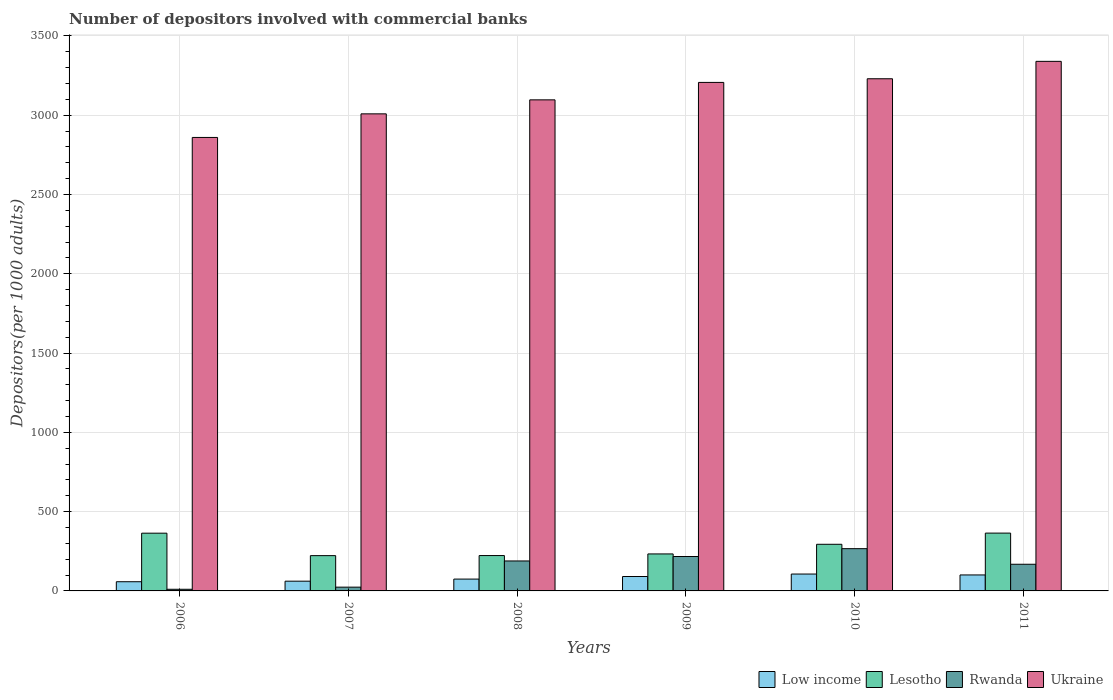How many groups of bars are there?
Offer a very short reply. 6. Are the number of bars per tick equal to the number of legend labels?
Keep it short and to the point. Yes. How many bars are there on the 3rd tick from the left?
Make the answer very short. 4. In how many cases, is the number of bars for a given year not equal to the number of legend labels?
Make the answer very short. 0. What is the number of depositors involved with commercial banks in Low income in 2008?
Provide a succinct answer. 74.6. Across all years, what is the maximum number of depositors involved with commercial banks in Lesotho?
Your response must be concise. 364.57. Across all years, what is the minimum number of depositors involved with commercial banks in Ukraine?
Provide a succinct answer. 2859.61. What is the total number of depositors involved with commercial banks in Ukraine in the graph?
Provide a succinct answer. 1.87e+04. What is the difference between the number of depositors involved with commercial banks in Ukraine in 2008 and that in 2010?
Your answer should be compact. -133.02. What is the difference between the number of depositors involved with commercial banks in Ukraine in 2007 and the number of depositors involved with commercial banks in Low income in 2006?
Offer a terse response. 2950.4. What is the average number of depositors involved with commercial banks in Rwanda per year?
Make the answer very short. 145.79. In the year 2010, what is the difference between the number of depositors involved with commercial banks in Rwanda and number of depositors involved with commercial banks in Low income?
Offer a terse response. 159.97. In how many years, is the number of depositors involved with commercial banks in Lesotho greater than 1200?
Give a very brief answer. 0. What is the ratio of the number of depositors involved with commercial banks in Lesotho in 2007 to that in 2008?
Make the answer very short. 1. Is the difference between the number of depositors involved with commercial banks in Rwanda in 2006 and 2007 greater than the difference between the number of depositors involved with commercial banks in Low income in 2006 and 2007?
Your response must be concise. No. What is the difference between the highest and the second highest number of depositors involved with commercial banks in Lesotho?
Provide a short and direct response. 0.45. What is the difference between the highest and the lowest number of depositors involved with commercial banks in Rwanda?
Your answer should be very brief. 256.03. In how many years, is the number of depositors involved with commercial banks in Low income greater than the average number of depositors involved with commercial banks in Low income taken over all years?
Provide a succinct answer. 3. Is it the case that in every year, the sum of the number of depositors involved with commercial banks in Low income and number of depositors involved with commercial banks in Ukraine is greater than the sum of number of depositors involved with commercial banks in Lesotho and number of depositors involved with commercial banks in Rwanda?
Offer a very short reply. Yes. What does the 1st bar from the left in 2008 represents?
Your answer should be compact. Low income. What does the 3rd bar from the right in 2007 represents?
Ensure brevity in your answer.  Lesotho. How many bars are there?
Your response must be concise. 24. Are all the bars in the graph horizontal?
Keep it short and to the point. No. Does the graph contain any zero values?
Your answer should be compact. No. Does the graph contain grids?
Your response must be concise. Yes. Where does the legend appear in the graph?
Your answer should be compact. Bottom right. How many legend labels are there?
Your answer should be very brief. 4. How are the legend labels stacked?
Your answer should be compact. Horizontal. What is the title of the graph?
Your response must be concise. Number of depositors involved with commercial banks. What is the label or title of the X-axis?
Ensure brevity in your answer.  Years. What is the label or title of the Y-axis?
Your answer should be very brief. Depositors(per 1000 adults). What is the Depositors(per 1000 adults) of Low income in 2006?
Keep it short and to the point. 57.99. What is the Depositors(per 1000 adults) in Lesotho in 2006?
Provide a succinct answer. 364.12. What is the Depositors(per 1000 adults) of Rwanda in 2006?
Provide a succinct answer. 10.43. What is the Depositors(per 1000 adults) in Ukraine in 2006?
Your answer should be very brief. 2859.61. What is the Depositors(per 1000 adults) of Low income in 2007?
Offer a terse response. 61.41. What is the Depositors(per 1000 adults) in Lesotho in 2007?
Your answer should be very brief. 222.49. What is the Depositors(per 1000 adults) in Rwanda in 2007?
Provide a short and direct response. 23.75. What is the Depositors(per 1000 adults) in Ukraine in 2007?
Your response must be concise. 3008.39. What is the Depositors(per 1000 adults) of Low income in 2008?
Make the answer very short. 74.6. What is the Depositors(per 1000 adults) of Lesotho in 2008?
Ensure brevity in your answer.  223. What is the Depositors(per 1000 adults) in Rwanda in 2008?
Provide a short and direct response. 188.93. What is the Depositors(per 1000 adults) in Ukraine in 2008?
Offer a very short reply. 3096.67. What is the Depositors(per 1000 adults) of Low income in 2009?
Ensure brevity in your answer.  90.91. What is the Depositors(per 1000 adults) in Lesotho in 2009?
Your answer should be compact. 233.31. What is the Depositors(per 1000 adults) in Rwanda in 2009?
Provide a succinct answer. 217.05. What is the Depositors(per 1000 adults) in Ukraine in 2009?
Keep it short and to the point. 3206.64. What is the Depositors(per 1000 adults) of Low income in 2010?
Your answer should be compact. 106.49. What is the Depositors(per 1000 adults) of Lesotho in 2010?
Your answer should be very brief. 294.05. What is the Depositors(per 1000 adults) in Rwanda in 2010?
Make the answer very short. 266.46. What is the Depositors(per 1000 adults) in Ukraine in 2010?
Give a very brief answer. 3229.69. What is the Depositors(per 1000 adults) of Low income in 2011?
Offer a terse response. 100.75. What is the Depositors(per 1000 adults) of Lesotho in 2011?
Make the answer very short. 364.57. What is the Depositors(per 1000 adults) of Rwanda in 2011?
Provide a short and direct response. 168.11. What is the Depositors(per 1000 adults) of Ukraine in 2011?
Keep it short and to the point. 3339.41. Across all years, what is the maximum Depositors(per 1000 adults) in Low income?
Make the answer very short. 106.49. Across all years, what is the maximum Depositors(per 1000 adults) of Lesotho?
Your answer should be very brief. 364.57. Across all years, what is the maximum Depositors(per 1000 adults) in Rwanda?
Your response must be concise. 266.46. Across all years, what is the maximum Depositors(per 1000 adults) of Ukraine?
Offer a very short reply. 3339.41. Across all years, what is the minimum Depositors(per 1000 adults) of Low income?
Provide a short and direct response. 57.99. Across all years, what is the minimum Depositors(per 1000 adults) in Lesotho?
Your answer should be compact. 222.49. Across all years, what is the minimum Depositors(per 1000 adults) in Rwanda?
Provide a succinct answer. 10.43. Across all years, what is the minimum Depositors(per 1000 adults) in Ukraine?
Give a very brief answer. 2859.61. What is the total Depositors(per 1000 adults) of Low income in the graph?
Offer a terse response. 492.15. What is the total Depositors(per 1000 adults) of Lesotho in the graph?
Offer a very short reply. 1701.54. What is the total Depositors(per 1000 adults) in Rwanda in the graph?
Give a very brief answer. 874.72. What is the total Depositors(per 1000 adults) of Ukraine in the graph?
Your answer should be compact. 1.87e+04. What is the difference between the Depositors(per 1000 adults) in Low income in 2006 and that in 2007?
Your answer should be very brief. -3.42. What is the difference between the Depositors(per 1000 adults) of Lesotho in 2006 and that in 2007?
Keep it short and to the point. 141.63. What is the difference between the Depositors(per 1000 adults) of Rwanda in 2006 and that in 2007?
Make the answer very short. -13.32. What is the difference between the Depositors(per 1000 adults) of Ukraine in 2006 and that in 2007?
Offer a terse response. -148.78. What is the difference between the Depositors(per 1000 adults) of Low income in 2006 and that in 2008?
Your answer should be very brief. -16.61. What is the difference between the Depositors(per 1000 adults) of Lesotho in 2006 and that in 2008?
Keep it short and to the point. 141.11. What is the difference between the Depositors(per 1000 adults) of Rwanda in 2006 and that in 2008?
Your answer should be very brief. -178.5. What is the difference between the Depositors(per 1000 adults) in Ukraine in 2006 and that in 2008?
Make the answer very short. -237.06. What is the difference between the Depositors(per 1000 adults) of Low income in 2006 and that in 2009?
Ensure brevity in your answer.  -32.92. What is the difference between the Depositors(per 1000 adults) in Lesotho in 2006 and that in 2009?
Ensure brevity in your answer.  130.81. What is the difference between the Depositors(per 1000 adults) in Rwanda in 2006 and that in 2009?
Keep it short and to the point. -206.62. What is the difference between the Depositors(per 1000 adults) of Ukraine in 2006 and that in 2009?
Keep it short and to the point. -347.03. What is the difference between the Depositors(per 1000 adults) of Low income in 2006 and that in 2010?
Offer a terse response. -48.5. What is the difference between the Depositors(per 1000 adults) of Lesotho in 2006 and that in 2010?
Keep it short and to the point. 70.06. What is the difference between the Depositors(per 1000 adults) of Rwanda in 2006 and that in 2010?
Your answer should be compact. -256.03. What is the difference between the Depositors(per 1000 adults) of Ukraine in 2006 and that in 2010?
Provide a succinct answer. -370.08. What is the difference between the Depositors(per 1000 adults) in Low income in 2006 and that in 2011?
Keep it short and to the point. -42.76. What is the difference between the Depositors(per 1000 adults) of Lesotho in 2006 and that in 2011?
Ensure brevity in your answer.  -0.45. What is the difference between the Depositors(per 1000 adults) in Rwanda in 2006 and that in 2011?
Your answer should be very brief. -157.68. What is the difference between the Depositors(per 1000 adults) in Ukraine in 2006 and that in 2011?
Your answer should be compact. -479.8. What is the difference between the Depositors(per 1000 adults) of Low income in 2007 and that in 2008?
Give a very brief answer. -13.19. What is the difference between the Depositors(per 1000 adults) of Lesotho in 2007 and that in 2008?
Keep it short and to the point. -0.51. What is the difference between the Depositors(per 1000 adults) in Rwanda in 2007 and that in 2008?
Your response must be concise. -165.19. What is the difference between the Depositors(per 1000 adults) of Ukraine in 2007 and that in 2008?
Provide a succinct answer. -88.28. What is the difference between the Depositors(per 1000 adults) of Low income in 2007 and that in 2009?
Offer a very short reply. -29.5. What is the difference between the Depositors(per 1000 adults) in Lesotho in 2007 and that in 2009?
Provide a succinct answer. -10.82. What is the difference between the Depositors(per 1000 adults) of Rwanda in 2007 and that in 2009?
Provide a succinct answer. -193.3. What is the difference between the Depositors(per 1000 adults) in Ukraine in 2007 and that in 2009?
Keep it short and to the point. -198.25. What is the difference between the Depositors(per 1000 adults) of Low income in 2007 and that in 2010?
Provide a short and direct response. -45.08. What is the difference between the Depositors(per 1000 adults) in Lesotho in 2007 and that in 2010?
Offer a terse response. -71.56. What is the difference between the Depositors(per 1000 adults) in Rwanda in 2007 and that in 2010?
Offer a very short reply. -242.71. What is the difference between the Depositors(per 1000 adults) of Ukraine in 2007 and that in 2010?
Make the answer very short. -221.3. What is the difference between the Depositors(per 1000 adults) of Low income in 2007 and that in 2011?
Offer a terse response. -39.34. What is the difference between the Depositors(per 1000 adults) in Lesotho in 2007 and that in 2011?
Offer a terse response. -142.08. What is the difference between the Depositors(per 1000 adults) of Rwanda in 2007 and that in 2011?
Your response must be concise. -144.36. What is the difference between the Depositors(per 1000 adults) of Ukraine in 2007 and that in 2011?
Your answer should be compact. -331.02. What is the difference between the Depositors(per 1000 adults) of Low income in 2008 and that in 2009?
Your response must be concise. -16.31. What is the difference between the Depositors(per 1000 adults) in Lesotho in 2008 and that in 2009?
Offer a very short reply. -10.3. What is the difference between the Depositors(per 1000 adults) in Rwanda in 2008 and that in 2009?
Make the answer very short. -28.11. What is the difference between the Depositors(per 1000 adults) of Ukraine in 2008 and that in 2009?
Ensure brevity in your answer.  -109.97. What is the difference between the Depositors(per 1000 adults) in Low income in 2008 and that in 2010?
Your answer should be very brief. -31.89. What is the difference between the Depositors(per 1000 adults) of Lesotho in 2008 and that in 2010?
Make the answer very short. -71.05. What is the difference between the Depositors(per 1000 adults) in Rwanda in 2008 and that in 2010?
Provide a succinct answer. -77.52. What is the difference between the Depositors(per 1000 adults) of Ukraine in 2008 and that in 2010?
Your response must be concise. -133.02. What is the difference between the Depositors(per 1000 adults) of Low income in 2008 and that in 2011?
Keep it short and to the point. -26.15. What is the difference between the Depositors(per 1000 adults) of Lesotho in 2008 and that in 2011?
Ensure brevity in your answer.  -141.56. What is the difference between the Depositors(per 1000 adults) in Rwanda in 2008 and that in 2011?
Keep it short and to the point. 20.82. What is the difference between the Depositors(per 1000 adults) in Ukraine in 2008 and that in 2011?
Provide a short and direct response. -242.74. What is the difference between the Depositors(per 1000 adults) in Low income in 2009 and that in 2010?
Offer a very short reply. -15.58. What is the difference between the Depositors(per 1000 adults) of Lesotho in 2009 and that in 2010?
Ensure brevity in your answer.  -60.75. What is the difference between the Depositors(per 1000 adults) in Rwanda in 2009 and that in 2010?
Your answer should be very brief. -49.41. What is the difference between the Depositors(per 1000 adults) of Ukraine in 2009 and that in 2010?
Offer a terse response. -23.06. What is the difference between the Depositors(per 1000 adults) in Low income in 2009 and that in 2011?
Provide a short and direct response. -9.84. What is the difference between the Depositors(per 1000 adults) of Lesotho in 2009 and that in 2011?
Offer a terse response. -131.26. What is the difference between the Depositors(per 1000 adults) of Rwanda in 2009 and that in 2011?
Keep it short and to the point. 48.94. What is the difference between the Depositors(per 1000 adults) in Ukraine in 2009 and that in 2011?
Provide a succinct answer. -132.77. What is the difference between the Depositors(per 1000 adults) of Low income in 2010 and that in 2011?
Offer a terse response. 5.74. What is the difference between the Depositors(per 1000 adults) in Lesotho in 2010 and that in 2011?
Your response must be concise. -70.51. What is the difference between the Depositors(per 1000 adults) of Rwanda in 2010 and that in 2011?
Your answer should be compact. 98.35. What is the difference between the Depositors(per 1000 adults) in Ukraine in 2010 and that in 2011?
Give a very brief answer. -109.71. What is the difference between the Depositors(per 1000 adults) in Low income in 2006 and the Depositors(per 1000 adults) in Lesotho in 2007?
Ensure brevity in your answer.  -164.5. What is the difference between the Depositors(per 1000 adults) in Low income in 2006 and the Depositors(per 1000 adults) in Rwanda in 2007?
Your answer should be compact. 34.24. What is the difference between the Depositors(per 1000 adults) in Low income in 2006 and the Depositors(per 1000 adults) in Ukraine in 2007?
Your response must be concise. -2950.4. What is the difference between the Depositors(per 1000 adults) in Lesotho in 2006 and the Depositors(per 1000 adults) in Rwanda in 2007?
Give a very brief answer. 340.37. What is the difference between the Depositors(per 1000 adults) in Lesotho in 2006 and the Depositors(per 1000 adults) in Ukraine in 2007?
Offer a very short reply. -2644.27. What is the difference between the Depositors(per 1000 adults) of Rwanda in 2006 and the Depositors(per 1000 adults) of Ukraine in 2007?
Offer a very short reply. -2997.96. What is the difference between the Depositors(per 1000 adults) of Low income in 2006 and the Depositors(per 1000 adults) of Lesotho in 2008?
Your answer should be very brief. -165.01. What is the difference between the Depositors(per 1000 adults) in Low income in 2006 and the Depositors(per 1000 adults) in Rwanda in 2008?
Ensure brevity in your answer.  -130.94. What is the difference between the Depositors(per 1000 adults) of Low income in 2006 and the Depositors(per 1000 adults) of Ukraine in 2008?
Keep it short and to the point. -3038.68. What is the difference between the Depositors(per 1000 adults) of Lesotho in 2006 and the Depositors(per 1000 adults) of Rwanda in 2008?
Offer a very short reply. 175.18. What is the difference between the Depositors(per 1000 adults) in Lesotho in 2006 and the Depositors(per 1000 adults) in Ukraine in 2008?
Provide a short and direct response. -2732.55. What is the difference between the Depositors(per 1000 adults) in Rwanda in 2006 and the Depositors(per 1000 adults) in Ukraine in 2008?
Ensure brevity in your answer.  -3086.24. What is the difference between the Depositors(per 1000 adults) in Low income in 2006 and the Depositors(per 1000 adults) in Lesotho in 2009?
Give a very brief answer. -175.32. What is the difference between the Depositors(per 1000 adults) of Low income in 2006 and the Depositors(per 1000 adults) of Rwanda in 2009?
Make the answer very short. -159.06. What is the difference between the Depositors(per 1000 adults) of Low income in 2006 and the Depositors(per 1000 adults) of Ukraine in 2009?
Offer a very short reply. -3148.65. What is the difference between the Depositors(per 1000 adults) in Lesotho in 2006 and the Depositors(per 1000 adults) in Rwanda in 2009?
Your answer should be very brief. 147.07. What is the difference between the Depositors(per 1000 adults) of Lesotho in 2006 and the Depositors(per 1000 adults) of Ukraine in 2009?
Provide a succinct answer. -2842.52. What is the difference between the Depositors(per 1000 adults) in Rwanda in 2006 and the Depositors(per 1000 adults) in Ukraine in 2009?
Keep it short and to the point. -3196.21. What is the difference between the Depositors(per 1000 adults) of Low income in 2006 and the Depositors(per 1000 adults) of Lesotho in 2010?
Your response must be concise. -236.06. What is the difference between the Depositors(per 1000 adults) of Low income in 2006 and the Depositors(per 1000 adults) of Rwanda in 2010?
Your answer should be compact. -208.47. What is the difference between the Depositors(per 1000 adults) in Low income in 2006 and the Depositors(per 1000 adults) in Ukraine in 2010?
Make the answer very short. -3171.7. What is the difference between the Depositors(per 1000 adults) of Lesotho in 2006 and the Depositors(per 1000 adults) of Rwanda in 2010?
Your answer should be very brief. 97.66. What is the difference between the Depositors(per 1000 adults) in Lesotho in 2006 and the Depositors(per 1000 adults) in Ukraine in 2010?
Ensure brevity in your answer.  -2865.58. What is the difference between the Depositors(per 1000 adults) of Rwanda in 2006 and the Depositors(per 1000 adults) of Ukraine in 2010?
Ensure brevity in your answer.  -3219.26. What is the difference between the Depositors(per 1000 adults) of Low income in 2006 and the Depositors(per 1000 adults) of Lesotho in 2011?
Offer a very short reply. -306.58. What is the difference between the Depositors(per 1000 adults) in Low income in 2006 and the Depositors(per 1000 adults) in Rwanda in 2011?
Ensure brevity in your answer.  -110.12. What is the difference between the Depositors(per 1000 adults) of Low income in 2006 and the Depositors(per 1000 adults) of Ukraine in 2011?
Your response must be concise. -3281.42. What is the difference between the Depositors(per 1000 adults) in Lesotho in 2006 and the Depositors(per 1000 adults) in Rwanda in 2011?
Your answer should be very brief. 196.01. What is the difference between the Depositors(per 1000 adults) of Lesotho in 2006 and the Depositors(per 1000 adults) of Ukraine in 2011?
Ensure brevity in your answer.  -2975.29. What is the difference between the Depositors(per 1000 adults) in Rwanda in 2006 and the Depositors(per 1000 adults) in Ukraine in 2011?
Your answer should be compact. -3328.98. What is the difference between the Depositors(per 1000 adults) in Low income in 2007 and the Depositors(per 1000 adults) in Lesotho in 2008?
Provide a short and direct response. -161.6. What is the difference between the Depositors(per 1000 adults) of Low income in 2007 and the Depositors(per 1000 adults) of Rwanda in 2008?
Make the answer very short. -127.53. What is the difference between the Depositors(per 1000 adults) in Low income in 2007 and the Depositors(per 1000 adults) in Ukraine in 2008?
Provide a succinct answer. -3035.26. What is the difference between the Depositors(per 1000 adults) of Lesotho in 2007 and the Depositors(per 1000 adults) of Rwanda in 2008?
Make the answer very short. 33.56. What is the difference between the Depositors(per 1000 adults) in Lesotho in 2007 and the Depositors(per 1000 adults) in Ukraine in 2008?
Provide a short and direct response. -2874.18. What is the difference between the Depositors(per 1000 adults) in Rwanda in 2007 and the Depositors(per 1000 adults) in Ukraine in 2008?
Make the answer very short. -3072.92. What is the difference between the Depositors(per 1000 adults) of Low income in 2007 and the Depositors(per 1000 adults) of Lesotho in 2009?
Provide a succinct answer. -171.9. What is the difference between the Depositors(per 1000 adults) of Low income in 2007 and the Depositors(per 1000 adults) of Rwanda in 2009?
Your answer should be very brief. -155.64. What is the difference between the Depositors(per 1000 adults) in Low income in 2007 and the Depositors(per 1000 adults) in Ukraine in 2009?
Keep it short and to the point. -3145.23. What is the difference between the Depositors(per 1000 adults) of Lesotho in 2007 and the Depositors(per 1000 adults) of Rwanda in 2009?
Your answer should be compact. 5.45. What is the difference between the Depositors(per 1000 adults) in Lesotho in 2007 and the Depositors(per 1000 adults) in Ukraine in 2009?
Provide a short and direct response. -2984.15. What is the difference between the Depositors(per 1000 adults) of Rwanda in 2007 and the Depositors(per 1000 adults) of Ukraine in 2009?
Your answer should be compact. -3182.89. What is the difference between the Depositors(per 1000 adults) in Low income in 2007 and the Depositors(per 1000 adults) in Lesotho in 2010?
Ensure brevity in your answer.  -232.65. What is the difference between the Depositors(per 1000 adults) in Low income in 2007 and the Depositors(per 1000 adults) in Rwanda in 2010?
Your answer should be very brief. -205.05. What is the difference between the Depositors(per 1000 adults) in Low income in 2007 and the Depositors(per 1000 adults) in Ukraine in 2010?
Provide a succinct answer. -3168.28. What is the difference between the Depositors(per 1000 adults) of Lesotho in 2007 and the Depositors(per 1000 adults) of Rwanda in 2010?
Ensure brevity in your answer.  -43.97. What is the difference between the Depositors(per 1000 adults) in Lesotho in 2007 and the Depositors(per 1000 adults) in Ukraine in 2010?
Make the answer very short. -3007.2. What is the difference between the Depositors(per 1000 adults) of Rwanda in 2007 and the Depositors(per 1000 adults) of Ukraine in 2010?
Keep it short and to the point. -3205.95. What is the difference between the Depositors(per 1000 adults) of Low income in 2007 and the Depositors(per 1000 adults) of Lesotho in 2011?
Your response must be concise. -303.16. What is the difference between the Depositors(per 1000 adults) of Low income in 2007 and the Depositors(per 1000 adults) of Rwanda in 2011?
Give a very brief answer. -106.7. What is the difference between the Depositors(per 1000 adults) in Low income in 2007 and the Depositors(per 1000 adults) in Ukraine in 2011?
Your response must be concise. -3278. What is the difference between the Depositors(per 1000 adults) in Lesotho in 2007 and the Depositors(per 1000 adults) in Rwanda in 2011?
Provide a succinct answer. 54.38. What is the difference between the Depositors(per 1000 adults) in Lesotho in 2007 and the Depositors(per 1000 adults) in Ukraine in 2011?
Your answer should be very brief. -3116.91. What is the difference between the Depositors(per 1000 adults) in Rwanda in 2007 and the Depositors(per 1000 adults) in Ukraine in 2011?
Your answer should be compact. -3315.66. What is the difference between the Depositors(per 1000 adults) of Low income in 2008 and the Depositors(per 1000 adults) of Lesotho in 2009?
Ensure brevity in your answer.  -158.71. What is the difference between the Depositors(per 1000 adults) of Low income in 2008 and the Depositors(per 1000 adults) of Rwanda in 2009?
Make the answer very short. -142.44. What is the difference between the Depositors(per 1000 adults) in Low income in 2008 and the Depositors(per 1000 adults) in Ukraine in 2009?
Provide a succinct answer. -3132.04. What is the difference between the Depositors(per 1000 adults) of Lesotho in 2008 and the Depositors(per 1000 adults) of Rwanda in 2009?
Offer a very short reply. 5.96. What is the difference between the Depositors(per 1000 adults) in Lesotho in 2008 and the Depositors(per 1000 adults) in Ukraine in 2009?
Offer a terse response. -2983.63. What is the difference between the Depositors(per 1000 adults) in Rwanda in 2008 and the Depositors(per 1000 adults) in Ukraine in 2009?
Offer a terse response. -3017.7. What is the difference between the Depositors(per 1000 adults) in Low income in 2008 and the Depositors(per 1000 adults) in Lesotho in 2010?
Offer a terse response. -219.45. What is the difference between the Depositors(per 1000 adults) of Low income in 2008 and the Depositors(per 1000 adults) of Rwanda in 2010?
Keep it short and to the point. -191.86. What is the difference between the Depositors(per 1000 adults) of Low income in 2008 and the Depositors(per 1000 adults) of Ukraine in 2010?
Your answer should be very brief. -3155.09. What is the difference between the Depositors(per 1000 adults) in Lesotho in 2008 and the Depositors(per 1000 adults) in Rwanda in 2010?
Offer a terse response. -43.45. What is the difference between the Depositors(per 1000 adults) of Lesotho in 2008 and the Depositors(per 1000 adults) of Ukraine in 2010?
Make the answer very short. -3006.69. What is the difference between the Depositors(per 1000 adults) of Rwanda in 2008 and the Depositors(per 1000 adults) of Ukraine in 2010?
Your answer should be compact. -3040.76. What is the difference between the Depositors(per 1000 adults) in Low income in 2008 and the Depositors(per 1000 adults) in Lesotho in 2011?
Your answer should be very brief. -289.97. What is the difference between the Depositors(per 1000 adults) of Low income in 2008 and the Depositors(per 1000 adults) of Rwanda in 2011?
Provide a short and direct response. -93.51. What is the difference between the Depositors(per 1000 adults) of Low income in 2008 and the Depositors(per 1000 adults) of Ukraine in 2011?
Offer a terse response. -3264.81. What is the difference between the Depositors(per 1000 adults) in Lesotho in 2008 and the Depositors(per 1000 adults) in Rwanda in 2011?
Make the answer very short. 54.89. What is the difference between the Depositors(per 1000 adults) of Lesotho in 2008 and the Depositors(per 1000 adults) of Ukraine in 2011?
Provide a succinct answer. -3116.4. What is the difference between the Depositors(per 1000 adults) of Rwanda in 2008 and the Depositors(per 1000 adults) of Ukraine in 2011?
Your answer should be very brief. -3150.47. What is the difference between the Depositors(per 1000 adults) of Low income in 2009 and the Depositors(per 1000 adults) of Lesotho in 2010?
Your answer should be very brief. -203.14. What is the difference between the Depositors(per 1000 adults) in Low income in 2009 and the Depositors(per 1000 adults) in Rwanda in 2010?
Offer a terse response. -175.55. What is the difference between the Depositors(per 1000 adults) in Low income in 2009 and the Depositors(per 1000 adults) in Ukraine in 2010?
Offer a very short reply. -3138.78. What is the difference between the Depositors(per 1000 adults) in Lesotho in 2009 and the Depositors(per 1000 adults) in Rwanda in 2010?
Keep it short and to the point. -33.15. What is the difference between the Depositors(per 1000 adults) of Lesotho in 2009 and the Depositors(per 1000 adults) of Ukraine in 2010?
Your answer should be compact. -2996.38. What is the difference between the Depositors(per 1000 adults) of Rwanda in 2009 and the Depositors(per 1000 adults) of Ukraine in 2010?
Keep it short and to the point. -3012.65. What is the difference between the Depositors(per 1000 adults) of Low income in 2009 and the Depositors(per 1000 adults) of Lesotho in 2011?
Offer a terse response. -273.66. What is the difference between the Depositors(per 1000 adults) of Low income in 2009 and the Depositors(per 1000 adults) of Rwanda in 2011?
Ensure brevity in your answer.  -77.2. What is the difference between the Depositors(per 1000 adults) of Low income in 2009 and the Depositors(per 1000 adults) of Ukraine in 2011?
Ensure brevity in your answer.  -3248.5. What is the difference between the Depositors(per 1000 adults) of Lesotho in 2009 and the Depositors(per 1000 adults) of Rwanda in 2011?
Keep it short and to the point. 65.2. What is the difference between the Depositors(per 1000 adults) in Lesotho in 2009 and the Depositors(per 1000 adults) in Ukraine in 2011?
Offer a terse response. -3106.1. What is the difference between the Depositors(per 1000 adults) in Rwanda in 2009 and the Depositors(per 1000 adults) in Ukraine in 2011?
Offer a very short reply. -3122.36. What is the difference between the Depositors(per 1000 adults) in Low income in 2010 and the Depositors(per 1000 adults) in Lesotho in 2011?
Your answer should be very brief. -258.08. What is the difference between the Depositors(per 1000 adults) of Low income in 2010 and the Depositors(per 1000 adults) of Rwanda in 2011?
Give a very brief answer. -61.62. What is the difference between the Depositors(per 1000 adults) of Low income in 2010 and the Depositors(per 1000 adults) of Ukraine in 2011?
Make the answer very short. -3232.92. What is the difference between the Depositors(per 1000 adults) of Lesotho in 2010 and the Depositors(per 1000 adults) of Rwanda in 2011?
Provide a succinct answer. 125.94. What is the difference between the Depositors(per 1000 adults) in Lesotho in 2010 and the Depositors(per 1000 adults) in Ukraine in 2011?
Ensure brevity in your answer.  -3045.35. What is the difference between the Depositors(per 1000 adults) in Rwanda in 2010 and the Depositors(per 1000 adults) in Ukraine in 2011?
Keep it short and to the point. -3072.95. What is the average Depositors(per 1000 adults) of Low income per year?
Your response must be concise. 82.02. What is the average Depositors(per 1000 adults) of Lesotho per year?
Ensure brevity in your answer.  283.59. What is the average Depositors(per 1000 adults) of Rwanda per year?
Keep it short and to the point. 145.79. What is the average Depositors(per 1000 adults) of Ukraine per year?
Your answer should be very brief. 3123.4. In the year 2006, what is the difference between the Depositors(per 1000 adults) of Low income and Depositors(per 1000 adults) of Lesotho?
Keep it short and to the point. -306.13. In the year 2006, what is the difference between the Depositors(per 1000 adults) in Low income and Depositors(per 1000 adults) in Rwanda?
Make the answer very short. 47.56. In the year 2006, what is the difference between the Depositors(per 1000 adults) in Low income and Depositors(per 1000 adults) in Ukraine?
Keep it short and to the point. -2801.62. In the year 2006, what is the difference between the Depositors(per 1000 adults) of Lesotho and Depositors(per 1000 adults) of Rwanda?
Provide a short and direct response. 353.69. In the year 2006, what is the difference between the Depositors(per 1000 adults) of Lesotho and Depositors(per 1000 adults) of Ukraine?
Your response must be concise. -2495.49. In the year 2006, what is the difference between the Depositors(per 1000 adults) of Rwanda and Depositors(per 1000 adults) of Ukraine?
Give a very brief answer. -2849.18. In the year 2007, what is the difference between the Depositors(per 1000 adults) of Low income and Depositors(per 1000 adults) of Lesotho?
Your response must be concise. -161.08. In the year 2007, what is the difference between the Depositors(per 1000 adults) in Low income and Depositors(per 1000 adults) in Rwanda?
Make the answer very short. 37.66. In the year 2007, what is the difference between the Depositors(per 1000 adults) in Low income and Depositors(per 1000 adults) in Ukraine?
Provide a short and direct response. -2946.98. In the year 2007, what is the difference between the Depositors(per 1000 adults) in Lesotho and Depositors(per 1000 adults) in Rwanda?
Offer a terse response. 198.74. In the year 2007, what is the difference between the Depositors(per 1000 adults) in Lesotho and Depositors(per 1000 adults) in Ukraine?
Keep it short and to the point. -2785.9. In the year 2007, what is the difference between the Depositors(per 1000 adults) in Rwanda and Depositors(per 1000 adults) in Ukraine?
Offer a very short reply. -2984.64. In the year 2008, what is the difference between the Depositors(per 1000 adults) of Low income and Depositors(per 1000 adults) of Lesotho?
Make the answer very short. -148.4. In the year 2008, what is the difference between the Depositors(per 1000 adults) in Low income and Depositors(per 1000 adults) in Rwanda?
Provide a succinct answer. -114.33. In the year 2008, what is the difference between the Depositors(per 1000 adults) of Low income and Depositors(per 1000 adults) of Ukraine?
Your answer should be compact. -3022.07. In the year 2008, what is the difference between the Depositors(per 1000 adults) in Lesotho and Depositors(per 1000 adults) in Rwanda?
Offer a very short reply. 34.07. In the year 2008, what is the difference between the Depositors(per 1000 adults) of Lesotho and Depositors(per 1000 adults) of Ukraine?
Give a very brief answer. -2873.67. In the year 2008, what is the difference between the Depositors(per 1000 adults) in Rwanda and Depositors(per 1000 adults) in Ukraine?
Keep it short and to the point. -2907.73. In the year 2009, what is the difference between the Depositors(per 1000 adults) in Low income and Depositors(per 1000 adults) in Lesotho?
Offer a very short reply. -142.4. In the year 2009, what is the difference between the Depositors(per 1000 adults) of Low income and Depositors(per 1000 adults) of Rwanda?
Keep it short and to the point. -126.14. In the year 2009, what is the difference between the Depositors(per 1000 adults) in Low income and Depositors(per 1000 adults) in Ukraine?
Provide a succinct answer. -3115.73. In the year 2009, what is the difference between the Depositors(per 1000 adults) of Lesotho and Depositors(per 1000 adults) of Rwanda?
Keep it short and to the point. 16.26. In the year 2009, what is the difference between the Depositors(per 1000 adults) in Lesotho and Depositors(per 1000 adults) in Ukraine?
Offer a terse response. -2973.33. In the year 2009, what is the difference between the Depositors(per 1000 adults) of Rwanda and Depositors(per 1000 adults) of Ukraine?
Make the answer very short. -2989.59. In the year 2010, what is the difference between the Depositors(per 1000 adults) in Low income and Depositors(per 1000 adults) in Lesotho?
Your answer should be compact. -187.56. In the year 2010, what is the difference between the Depositors(per 1000 adults) in Low income and Depositors(per 1000 adults) in Rwanda?
Offer a very short reply. -159.97. In the year 2010, what is the difference between the Depositors(per 1000 adults) in Low income and Depositors(per 1000 adults) in Ukraine?
Offer a terse response. -3123.2. In the year 2010, what is the difference between the Depositors(per 1000 adults) of Lesotho and Depositors(per 1000 adults) of Rwanda?
Keep it short and to the point. 27.6. In the year 2010, what is the difference between the Depositors(per 1000 adults) of Lesotho and Depositors(per 1000 adults) of Ukraine?
Offer a terse response. -2935.64. In the year 2010, what is the difference between the Depositors(per 1000 adults) in Rwanda and Depositors(per 1000 adults) in Ukraine?
Keep it short and to the point. -2963.24. In the year 2011, what is the difference between the Depositors(per 1000 adults) in Low income and Depositors(per 1000 adults) in Lesotho?
Your answer should be very brief. -263.82. In the year 2011, what is the difference between the Depositors(per 1000 adults) in Low income and Depositors(per 1000 adults) in Rwanda?
Keep it short and to the point. -67.36. In the year 2011, what is the difference between the Depositors(per 1000 adults) of Low income and Depositors(per 1000 adults) of Ukraine?
Offer a terse response. -3238.66. In the year 2011, what is the difference between the Depositors(per 1000 adults) in Lesotho and Depositors(per 1000 adults) in Rwanda?
Provide a succinct answer. 196.46. In the year 2011, what is the difference between the Depositors(per 1000 adults) of Lesotho and Depositors(per 1000 adults) of Ukraine?
Your answer should be very brief. -2974.84. In the year 2011, what is the difference between the Depositors(per 1000 adults) in Rwanda and Depositors(per 1000 adults) in Ukraine?
Offer a very short reply. -3171.3. What is the ratio of the Depositors(per 1000 adults) of Low income in 2006 to that in 2007?
Keep it short and to the point. 0.94. What is the ratio of the Depositors(per 1000 adults) of Lesotho in 2006 to that in 2007?
Keep it short and to the point. 1.64. What is the ratio of the Depositors(per 1000 adults) of Rwanda in 2006 to that in 2007?
Offer a very short reply. 0.44. What is the ratio of the Depositors(per 1000 adults) of Ukraine in 2006 to that in 2007?
Provide a succinct answer. 0.95. What is the ratio of the Depositors(per 1000 adults) of Low income in 2006 to that in 2008?
Your response must be concise. 0.78. What is the ratio of the Depositors(per 1000 adults) of Lesotho in 2006 to that in 2008?
Your response must be concise. 1.63. What is the ratio of the Depositors(per 1000 adults) in Rwanda in 2006 to that in 2008?
Offer a terse response. 0.06. What is the ratio of the Depositors(per 1000 adults) of Ukraine in 2006 to that in 2008?
Ensure brevity in your answer.  0.92. What is the ratio of the Depositors(per 1000 adults) of Low income in 2006 to that in 2009?
Ensure brevity in your answer.  0.64. What is the ratio of the Depositors(per 1000 adults) in Lesotho in 2006 to that in 2009?
Your answer should be compact. 1.56. What is the ratio of the Depositors(per 1000 adults) of Rwanda in 2006 to that in 2009?
Your response must be concise. 0.05. What is the ratio of the Depositors(per 1000 adults) in Ukraine in 2006 to that in 2009?
Ensure brevity in your answer.  0.89. What is the ratio of the Depositors(per 1000 adults) in Low income in 2006 to that in 2010?
Ensure brevity in your answer.  0.54. What is the ratio of the Depositors(per 1000 adults) of Lesotho in 2006 to that in 2010?
Provide a succinct answer. 1.24. What is the ratio of the Depositors(per 1000 adults) in Rwanda in 2006 to that in 2010?
Your answer should be compact. 0.04. What is the ratio of the Depositors(per 1000 adults) in Ukraine in 2006 to that in 2010?
Keep it short and to the point. 0.89. What is the ratio of the Depositors(per 1000 adults) in Low income in 2006 to that in 2011?
Your answer should be very brief. 0.58. What is the ratio of the Depositors(per 1000 adults) of Lesotho in 2006 to that in 2011?
Provide a short and direct response. 1. What is the ratio of the Depositors(per 1000 adults) in Rwanda in 2006 to that in 2011?
Provide a short and direct response. 0.06. What is the ratio of the Depositors(per 1000 adults) in Ukraine in 2006 to that in 2011?
Provide a succinct answer. 0.86. What is the ratio of the Depositors(per 1000 adults) in Low income in 2007 to that in 2008?
Give a very brief answer. 0.82. What is the ratio of the Depositors(per 1000 adults) in Lesotho in 2007 to that in 2008?
Your response must be concise. 1. What is the ratio of the Depositors(per 1000 adults) of Rwanda in 2007 to that in 2008?
Ensure brevity in your answer.  0.13. What is the ratio of the Depositors(per 1000 adults) in Ukraine in 2007 to that in 2008?
Offer a terse response. 0.97. What is the ratio of the Depositors(per 1000 adults) of Low income in 2007 to that in 2009?
Your answer should be compact. 0.68. What is the ratio of the Depositors(per 1000 adults) in Lesotho in 2007 to that in 2009?
Offer a terse response. 0.95. What is the ratio of the Depositors(per 1000 adults) in Rwanda in 2007 to that in 2009?
Offer a terse response. 0.11. What is the ratio of the Depositors(per 1000 adults) in Ukraine in 2007 to that in 2009?
Offer a very short reply. 0.94. What is the ratio of the Depositors(per 1000 adults) in Low income in 2007 to that in 2010?
Make the answer very short. 0.58. What is the ratio of the Depositors(per 1000 adults) of Lesotho in 2007 to that in 2010?
Make the answer very short. 0.76. What is the ratio of the Depositors(per 1000 adults) in Rwanda in 2007 to that in 2010?
Your response must be concise. 0.09. What is the ratio of the Depositors(per 1000 adults) in Ukraine in 2007 to that in 2010?
Provide a short and direct response. 0.93. What is the ratio of the Depositors(per 1000 adults) of Low income in 2007 to that in 2011?
Offer a very short reply. 0.61. What is the ratio of the Depositors(per 1000 adults) in Lesotho in 2007 to that in 2011?
Give a very brief answer. 0.61. What is the ratio of the Depositors(per 1000 adults) of Rwanda in 2007 to that in 2011?
Your response must be concise. 0.14. What is the ratio of the Depositors(per 1000 adults) of Ukraine in 2007 to that in 2011?
Keep it short and to the point. 0.9. What is the ratio of the Depositors(per 1000 adults) in Low income in 2008 to that in 2009?
Your answer should be very brief. 0.82. What is the ratio of the Depositors(per 1000 adults) of Lesotho in 2008 to that in 2009?
Offer a very short reply. 0.96. What is the ratio of the Depositors(per 1000 adults) in Rwanda in 2008 to that in 2009?
Provide a succinct answer. 0.87. What is the ratio of the Depositors(per 1000 adults) in Ukraine in 2008 to that in 2009?
Offer a very short reply. 0.97. What is the ratio of the Depositors(per 1000 adults) of Low income in 2008 to that in 2010?
Keep it short and to the point. 0.7. What is the ratio of the Depositors(per 1000 adults) of Lesotho in 2008 to that in 2010?
Your answer should be very brief. 0.76. What is the ratio of the Depositors(per 1000 adults) of Rwanda in 2008 to that in 2010?
Your answer should be compact. 0.71. What is the ratio of the Depositors(per 1000 adults) in Ukraine in 2008 to that in 2010?
Offer a terse response. 0.96. What is the ratio of the Depositors(per 1000 adults) in Low income in 2008 to that in 2011?
Your answer should be compact. 0.74. What is the ratio of the Depositors(per 1000 adults) of Lesotho in 2008 to that in 2011?
Offer a very short reply. 0.61. What is the ratio of the Depositors(per 1000 adults) in Rwanda in 2008 to that in 2011?
Make the answer very short. 1.12. What is the ratio of the Depositors(per 1000 adults) in Ukraine in 2008 to that in 2011?
Provide a short and direct response. 0.93. What is the ratio of the Depositors(per 1000 adults) in Low income in 2009 to that in 2010?
Your answer should be very brief. 0.85. What is the ratio of the Depositors(per 1000 adults) in Lesotho in 2009 to that in 2010?
Your response must be concise. 0.79. What is the ratio of the Depositors(per 1000 adults) in Rwanda in 2009 to that in 2010?
Provide a short and direct response. 0.81. What is the ratio of the Depositors(per 1000 adults) in Ukraine in 2009 to that in 2010?
Provide a succinct answer. 0.99. What is the ratio of the Depositors(per 1000 adults) of Low income in 2009 to that in 2011?
Your answer should be very brief. 0.9. What is the ratio of the Depositors(per 1000 adults) of Lesotho in 2009 to that in 2011?
Make the answer very short. 0.64. What is the ratio of the Depositors(per 1000 adults) in Rwanda in 2009 to that in 2011?
Offer a terse response. 1.29. What is the ratio of the Depositors(per 1000 adults) of Ukraine in 2009 to that in 2011?
Offer a very short reply. 0.96. What is the ratio of the Depositors(per 1000 adults) of Low income in 2010 to that in 2011?
Your answer should be very brief. 1.06. What is the ratio of the Depositors(per 1000 adults) in Lesotho in 2010 to that in 2011?
Your response must be concise. 0.81. What is the ratio of the Depositors(per 1000 adults) of Rwanda in 2010 to that in 2011?
Keep it short and to the point. 1.58. What is the ratio of the Depositors(per 1000 adults) of Ukraine in 2010 to that in 2011?
Keep it short and to the point. 0.97. What is the difference between the highest and the second highest Depositors(per 1000 adults) of Low income?
Your answer should be compact. 5.74. What is the difference between the highest and the second highest Depositors(per 1000 adults) of Lesotho?
Provide a short and direct response. 0.45. What is the difference between the highest and the second highest Depositors(per 1000 adults) of Rwanda?
Offer a very short reply. 49.41. What is the difference between the highest and the second highest Depositors(per 1000 adults) in Ukraine?
Provide a succinct answer. 109.71. What is the difference between the highest and the lowest Depositors(per 1000 adults) in Low income?
Offer a very short reply. 48.5. What is the difference between the highest and the lowest Depositors(per 1000 adults) in Lesotho?
Your response must be concise. 142.08. What is the difference between the highest and the lowest Depositors(per 1000 adults) in Rwanda?
Ensure brevity in your answer.  256.03. What is the difference between the highest and the lowest Depositors(per 1000 adults) in Ukraine?
Provide a short and direct response. 479.8. 